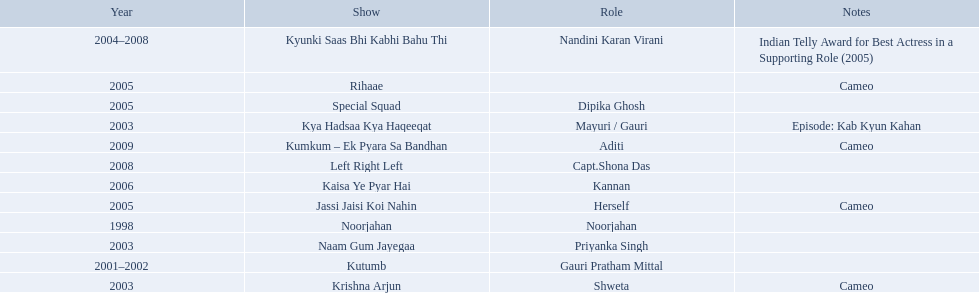What are all of the shows? Noorjahan, Kutumb, Krishna Arjun, Naam Gum Jayegaa, Kya Hadsaa Kya Haqeeqat, Kyunki Saas Bhi Kabhi Bahu Thi, Rihaae, Jassi Jaisi Koi Nahin, Special Squad, Kaisa Ye Pyar Hai, Left Right Left, Kumkum – Ek Pyara Sa Bandhan. When did they premiere? 1998, 2001–2002, 2003, 2003, 2003, 2004–2008, 2005, 2005, 2005, 2006, 2008, 2009. What notes are there for the shows from 2005? Cameo, Cameo. Parse the table in full. {'header': ['Year', 'Show', 'Role', 'Notes'], 'rows': [['2004–2008', 'Kyunki Saas Bhi Kabhi Bahu Thi', 'Nandini Karan Virani', 'Indian Telly Award for Best Actress in a Supporting Role (2005)'], ['2005', 'Rihaae', '', 'Cameo'], ['2005', 'Special Squad', 'Dipika Ghosh', ''], ['2003', 'Kya Hadsaa Kya Haqeeqat', 'Mayuri / Gauri', 'Episode: Kab Kyun Kahan'], ['2009', 'Kumkum – Ek Pyara Sa Bandhan', 'Aditi', 'Cameo'], ['2008', 'Left Right Left', 'Capt.Shona Das', ''], ['2006', 'Kaisa Ye Pyar Hai', 'Kannan', ''], ['2005', 'Jassi Jaisi Koi Nahin', 'Herself', 'Cameo'], ['1998', 'Noorjahan', 'Noorjahan', ''], ['2003', 'Naam Gum Jayegaa', 'Priyanka Singh', ''], ['2001–2002', 'Kutumb', 'Gauri Pratham Mittal', ''], ['2003', 'Krishna Arjun', 'Shweta', 'Cameo']]} Along with rihaee, what is the other show gauri had a cameo role in? Jassi Jaisi Koi Nahin. 